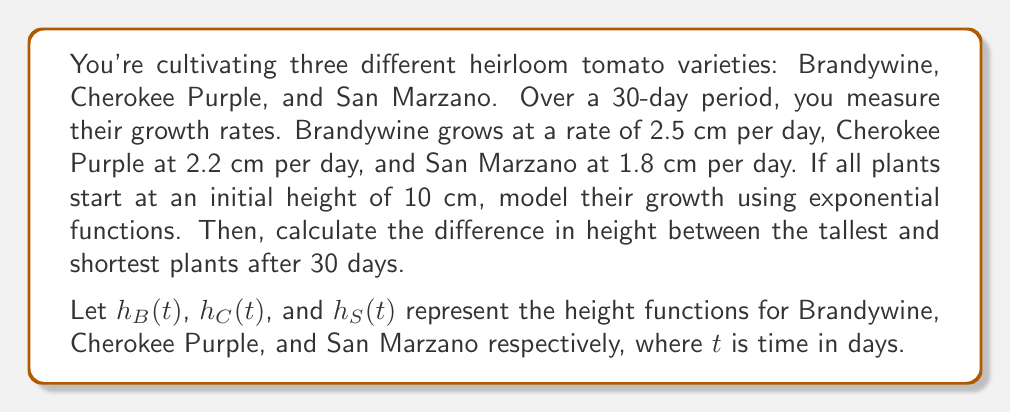Show me your answer to this math problem. To solve this problem, we'll follow these steps:

1) First, we need to convert the linear growth rates into exponential growth rates. The general form of an exponential growth function is:

   $h(t) = h_0 \cdot e^{rt}$

   where $h_0$ is the initial height, $e$ is Euler's number, $r$ is the growth rate, and $t$ is time.

2) To find $r$ for each variety, we use the formula:

   $r = \ln(1 + \frac{\text{daily growth}}{\text{initial height}})$

3) For Brandywine:
   $r_B = \ln(1 + \frac{2.5}{10}) \approx 0.2231$

4) For Cherokee Purple:
   $r_C = \ln(1 + \frac{2.2}{10}) \approx 0.1989$

5) For San Marzano:
   $r_S = \ln(1 + \frac{1.8}{10}) \approx 0.1655$

6) Now we can write our height functions:

   $h_B(t) = 10 \cdot e^{0.2231t}$
   $h_C(t) = 10 \cdot e^{0.1989t}$
   $h_S(t) = 10 \cdot e^{0.1655t}$

7) To find the heights after 30 days, we substitute $t = 30$ into each function:

   $h_B(30) = 10 \cdot e^{0.2231 \cdot 30} \approx 85.99$ cm
   $h_C(30) = 10 \cdot e^{0.1989 \cdot 30} \approx 76.15$ cm
   $h_S(30) = 10 \cdot e^{0.1655 \cdot 30} \approx 64.87$ cm

8) The difference between the tallest (Brandywine) and shortest (San Marzano) is:

   $85.99 - 64.87 = 21.12$ cm
Answer: The difference in height between the tallest and shortest plants after 30 days is approximately 21.12 cm. 